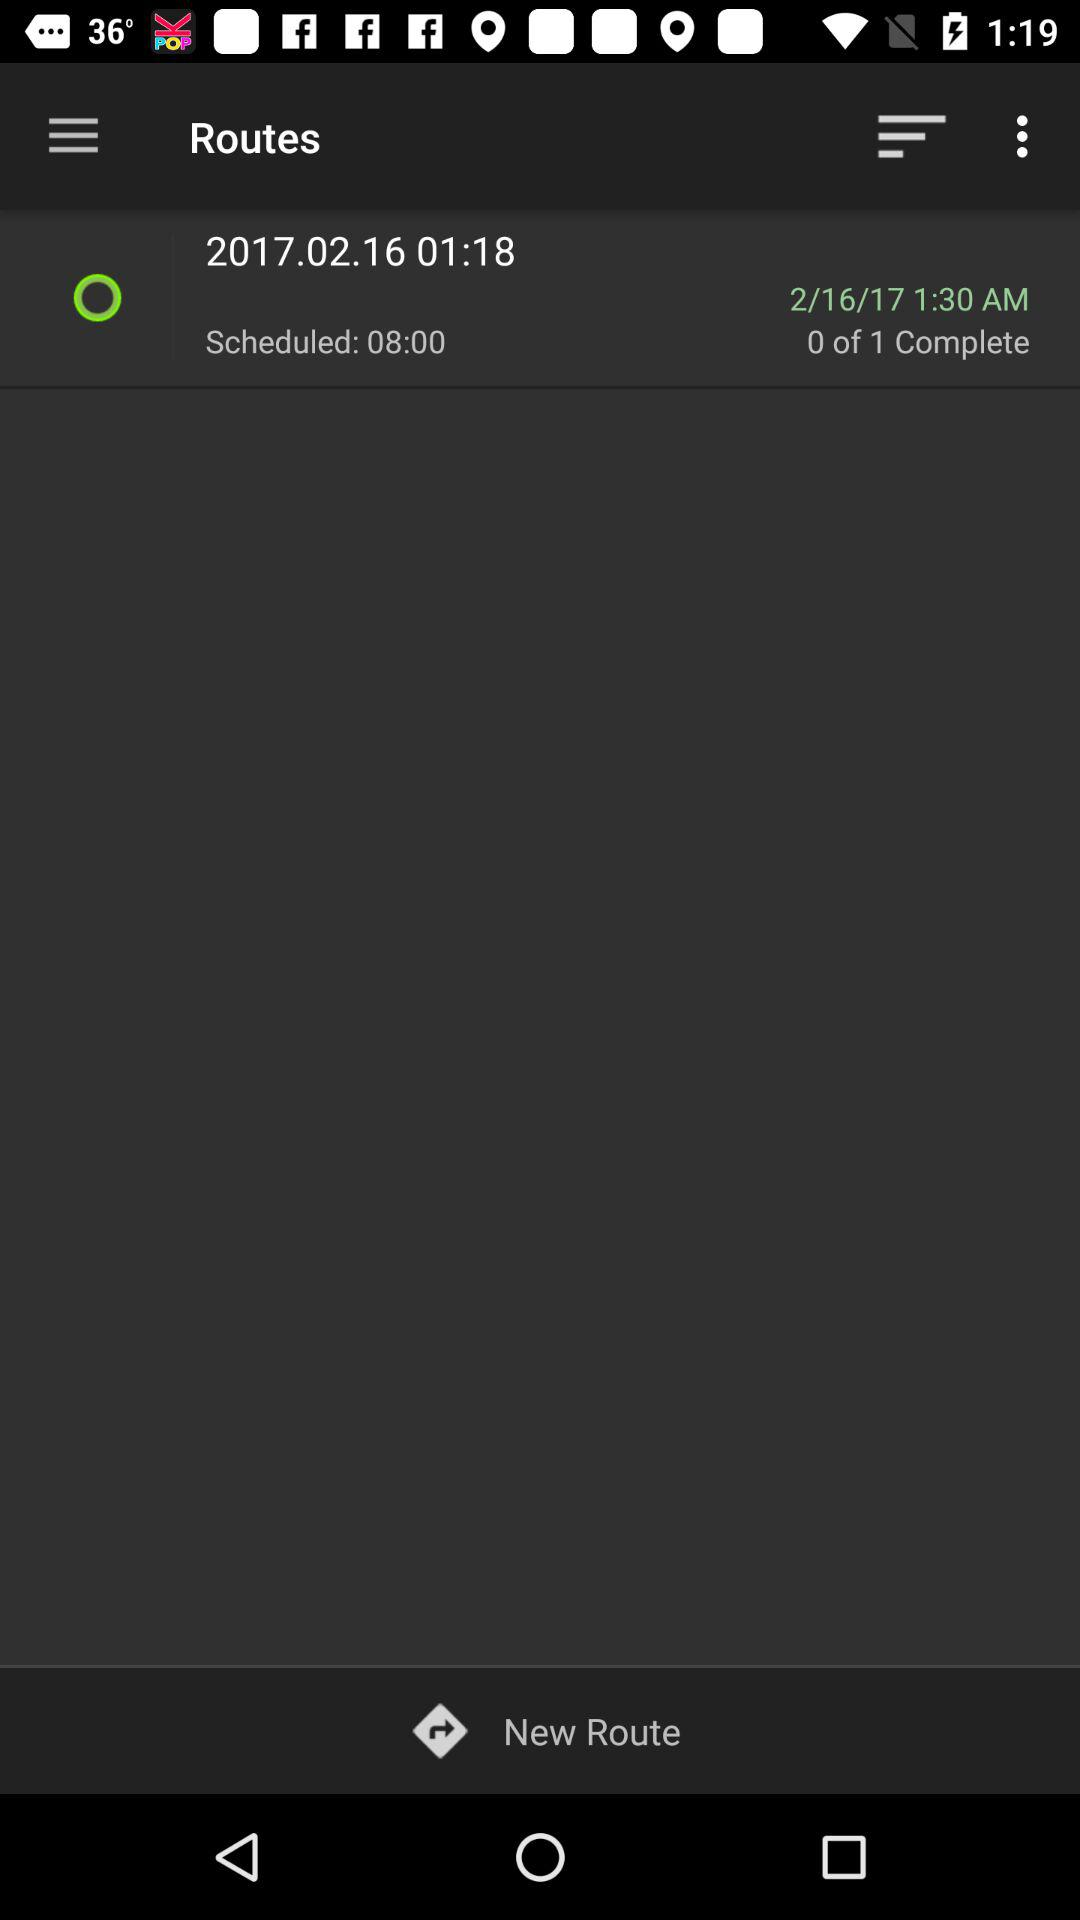What is the date? The date is February 16, 2017. 